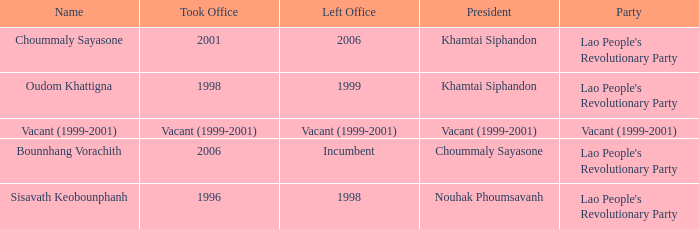What is Party, when Took Office is 1998? Lao People's Revolutionary Party. 